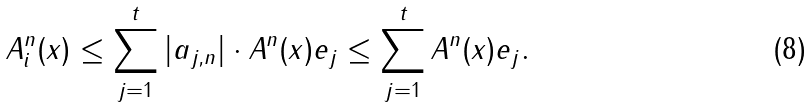<formula> <loc_0><loc_0><loc_500><loc_500>\| A _ { i } ^ { n } ( x ) \| \leq \sum _ { j = 1 } ^ { t } | a _ { j , n } | \cdot \| A ^ { n } ( x ) e _ { j } \| \leq \sum _ { j = 1 } ^ { t } \| A ^ { n } ( x ) e _ { j } \| .</formula> 